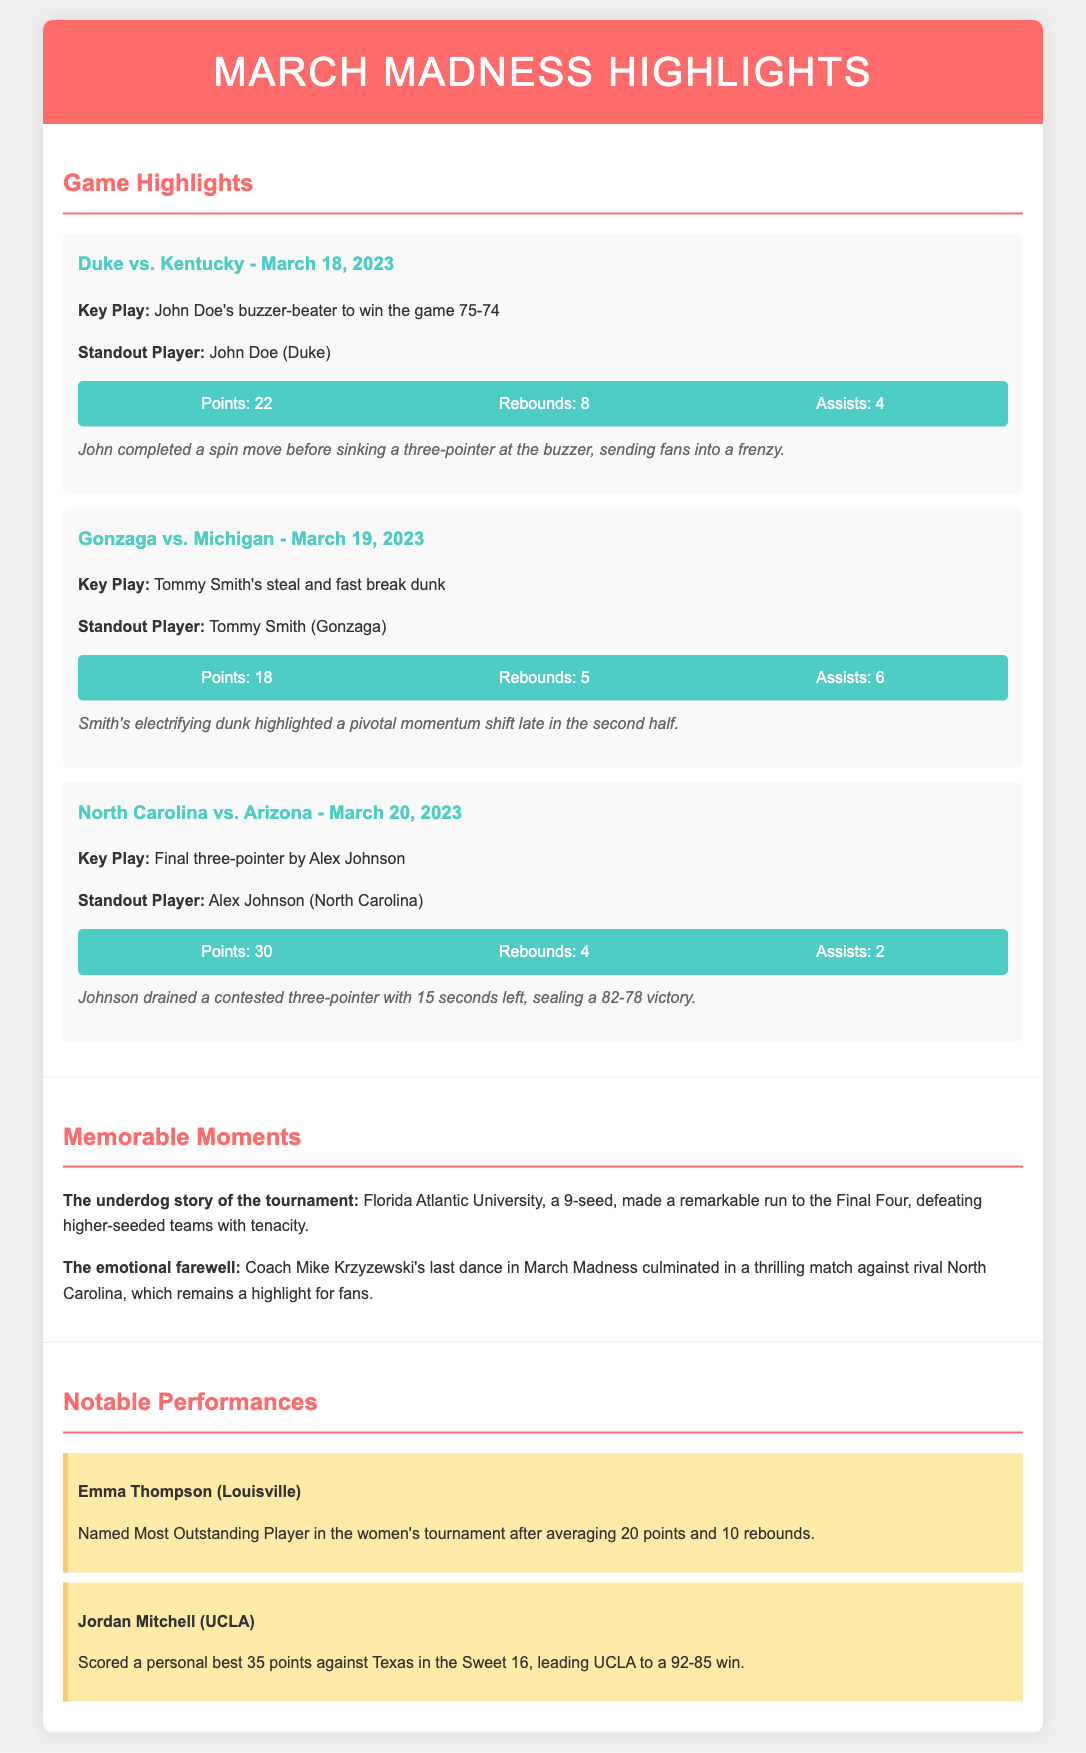What was the final score of the Duke vs. Kentucky game? The final score of the Duke vs. Kentucky game is mentioned in the key play section as 75-74.
Answer: 75-74 Who made the buzzer-beater in the Duke vs. Kentucky game? The key play section specifies that John Doe made the buzzer-beater in the Duke vs. Kentucky game.
Answer: John Doe What is Alex Johnson's total points in the North Carolina vs. Arizona game? The document states Alex Johnson scored 30 points in the North Carolina vs. Arizona game.
Answer: 30 Which player was recognized as the Most Outstanding Player in the women's tournament? The notable performance section highlights that Emma Thompson was named Most Outstanding Player in the women's tournament.
Answer: Emma Thompson What significant moment did Florida Atlantic University achieve in the tournament? The memorable moments section describes Florida Atlantic University's remarkable run to the Final Four as a significant achievement.
Answer: Final Four How many points did Jordan Mitchell score against Texas? The document notes that Jordan Mitchell scored a personal best of 35 points against Texas.
Answer: 35 What was Tommy Smith’s standout moment during the Gonzaga vs. Michigan game? The key play section mentions that Tommy Smith's standout moment was a steal and fast break dunk.
Answer: Steal and fast break dunk In what round did UCLA defeat Texas? The notable performances mention that UCLA defeated Texas in the Sweet 16.
Answer: Sweet 16 